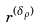<formula> <loc_0><loc_0><loc_500><loc_500>r ^ { ( \delta _ { \rho } ) }</formula> 